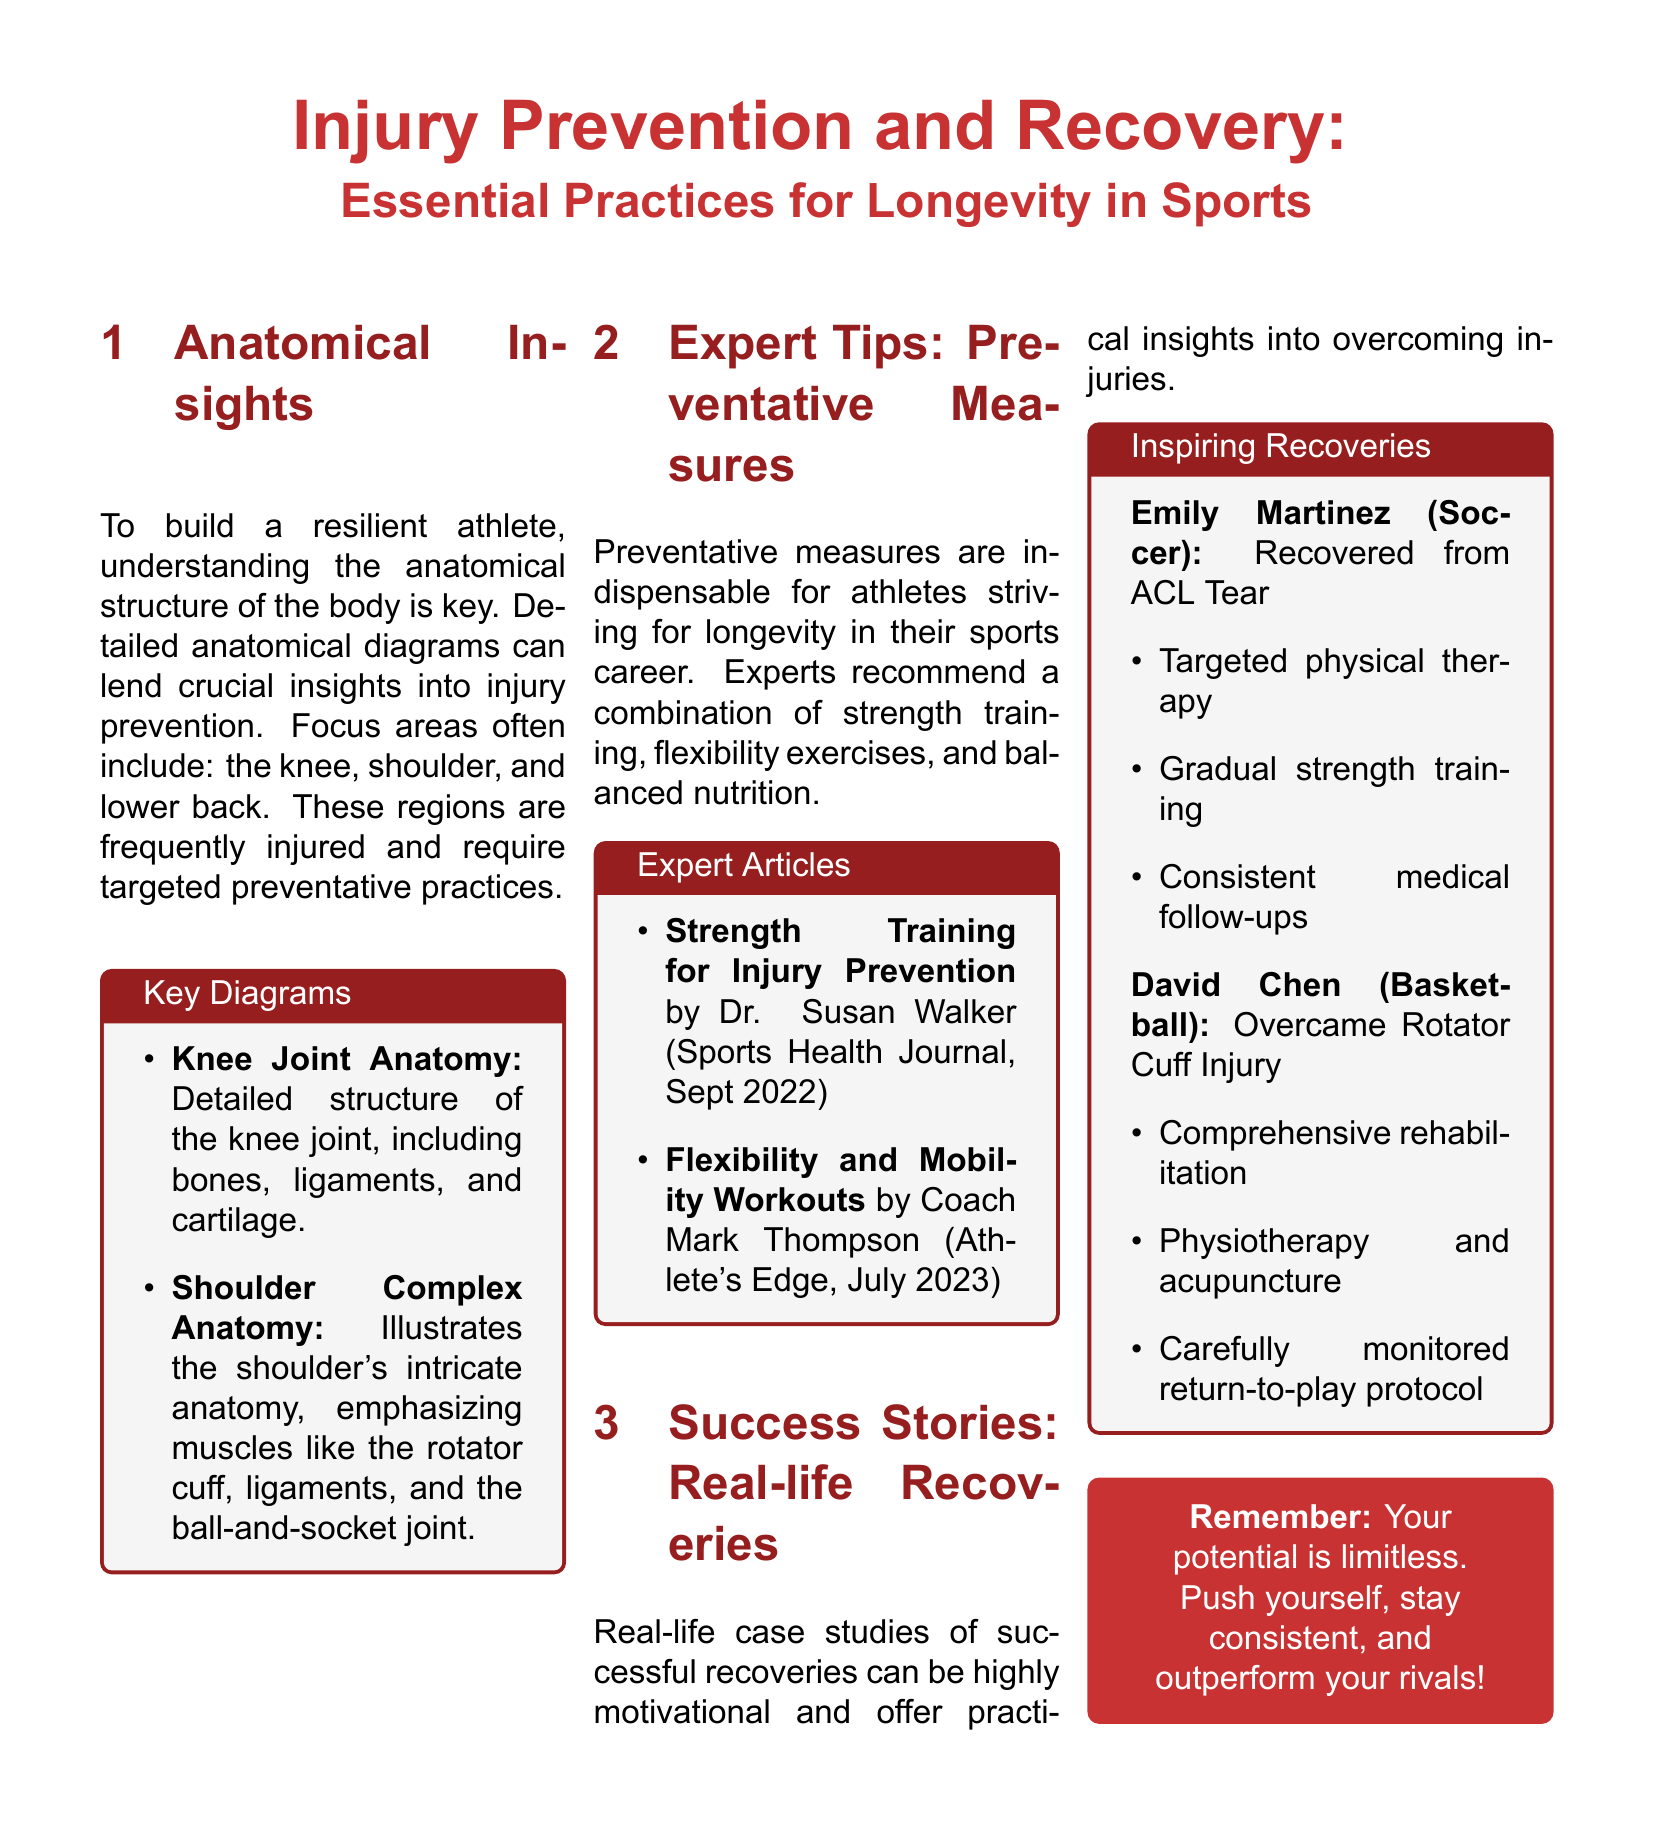What is the main topic of the document? The document focuses on practices related to injury prevention and recovery in sports.
Answer: Injury Prevention and Recovery Which joints are specifically mentioned as focus areas for injury prevention? The document highlights three main joints that are often injured: the knee, shoulder, and lower back.
Answer: Knee, shoulder, and lower back Who wrote the article on strength training for injury prevention? The document cites Dr. Susan Walker as the author of the strength training article.
Answer: Dr. Susan Walker How did Emily Martinez recover from her injury? Her recovery involved targeted physical therapy, gradual strength training, and consistent medical follow-ups.
Answer: Targeted physical therapy, gradual strength training, consistent medical follow-ups What is emphasized as essential for athlete longevity? The document stresses the importance of a combination of strength training, flexibility exercises, and balanced nutrition.
Answer: Strength training, flexibility exercises, balanced nutrition Which recovery method did David Chen use for his rotator cuff injury? He underwent comprehensive rehabilitation, physiotherapy, and acupuncture for his recovery.
Answer: Comprehensive rehabilitation, physiotherapy, acupuncture What structural element does the key diagram for the knee joint include? The knee joint anatomy diagram includes bones, ligaments, and cartilage.
Answer: Bones, ligaments, cartilage What motivational message is provided at the end of the document? The document encourages athletes to push themselves, stay consistent, and outperform their rivals.
Answer: Your potential is limitless 